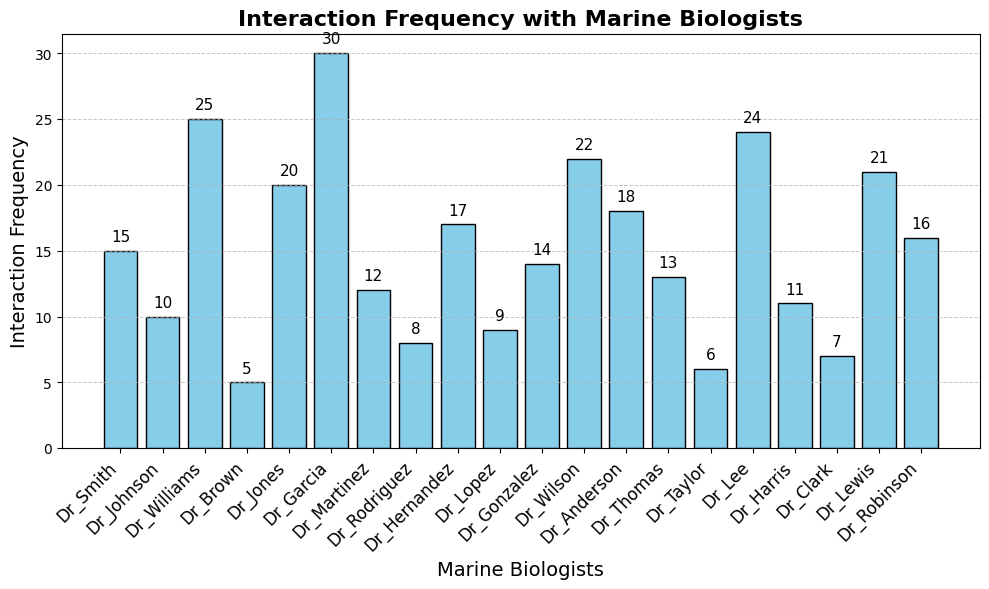Which marine biologist had the highest interaction frequency? Look at the bar with the greatest height; Dr. Garcia has the tallest bar at 30 interactions.
Answer: Dr. Garcia What is the difference in interaction frequency between Dr. Garcia and Dr. Lee? Dr. Garcia's bar is at a height of 30, and Dr. Lee's is at 24. Subtracting 24 from 30 gives 30 - 24 = 6.
Answer: 6 Which two marine biologists have the same interaction frequency? Observe the bars at the same height; Dr. Rodriguez and Dr. Clark both have a height of 8.
Answer: Dr. Rodriguez and Dr. Clark What is the average interaction frequency of Dr. Smith, Dr. Harris, and Dr. Robinson? Add the frequencies (15 + 11 + 16 = 42) and divide by 3: 42 / 3 = 14.
Answer: 14 How many marine biologists have an interaction frequency greater than 20? Count the bars with heights greater than 20; there are four: Dr. Garcia, Dr. Lee, Dr. Wilson, and Dr. Lewis.
Answer: 4 Which marine biologist had the least interaction frequency? Look at the bar with the smallest height; Dr. Brown has the shortest bar at 5 interactions.
Answer: Dr. Brown Which marine biologist had more interactions, Dr. Taylor or Dr. Johnson? Compare the heights of Dr. Taylor's bar (6) and Dr. Johnson's bar (10); Dr. Johnson's bar is taller.
Answer: Dr. Johnson What's the total number of interactions for Dr. Anderson, Dr. Williams, and Dr. Hernandez combined? Add their interaction frequencies (18 + 25 + 17). 18 + 25 + 17 = 60.
Answer: 60 Among Dr. Gonzalez, Dr. Harris, and Dr. Lopez, who has the highest interaction frequency? Compare the heights of the bars for Dr. Gonzalez (14), Dr. Harris (11), and Dr. Lopez (9); Dr. Gonzalez has the tallest bar.
Answer: Dr. Gonzalez Is the interaction frequency of Dr. Robinson closer to Dr. Lewis or Dr. Anderson? Dr. Robinson's interaction frequency is 16, Dr. Lewis's is 21, and Dr. Anderson's is 18. The difference is
Answer: Dr. Anderson 